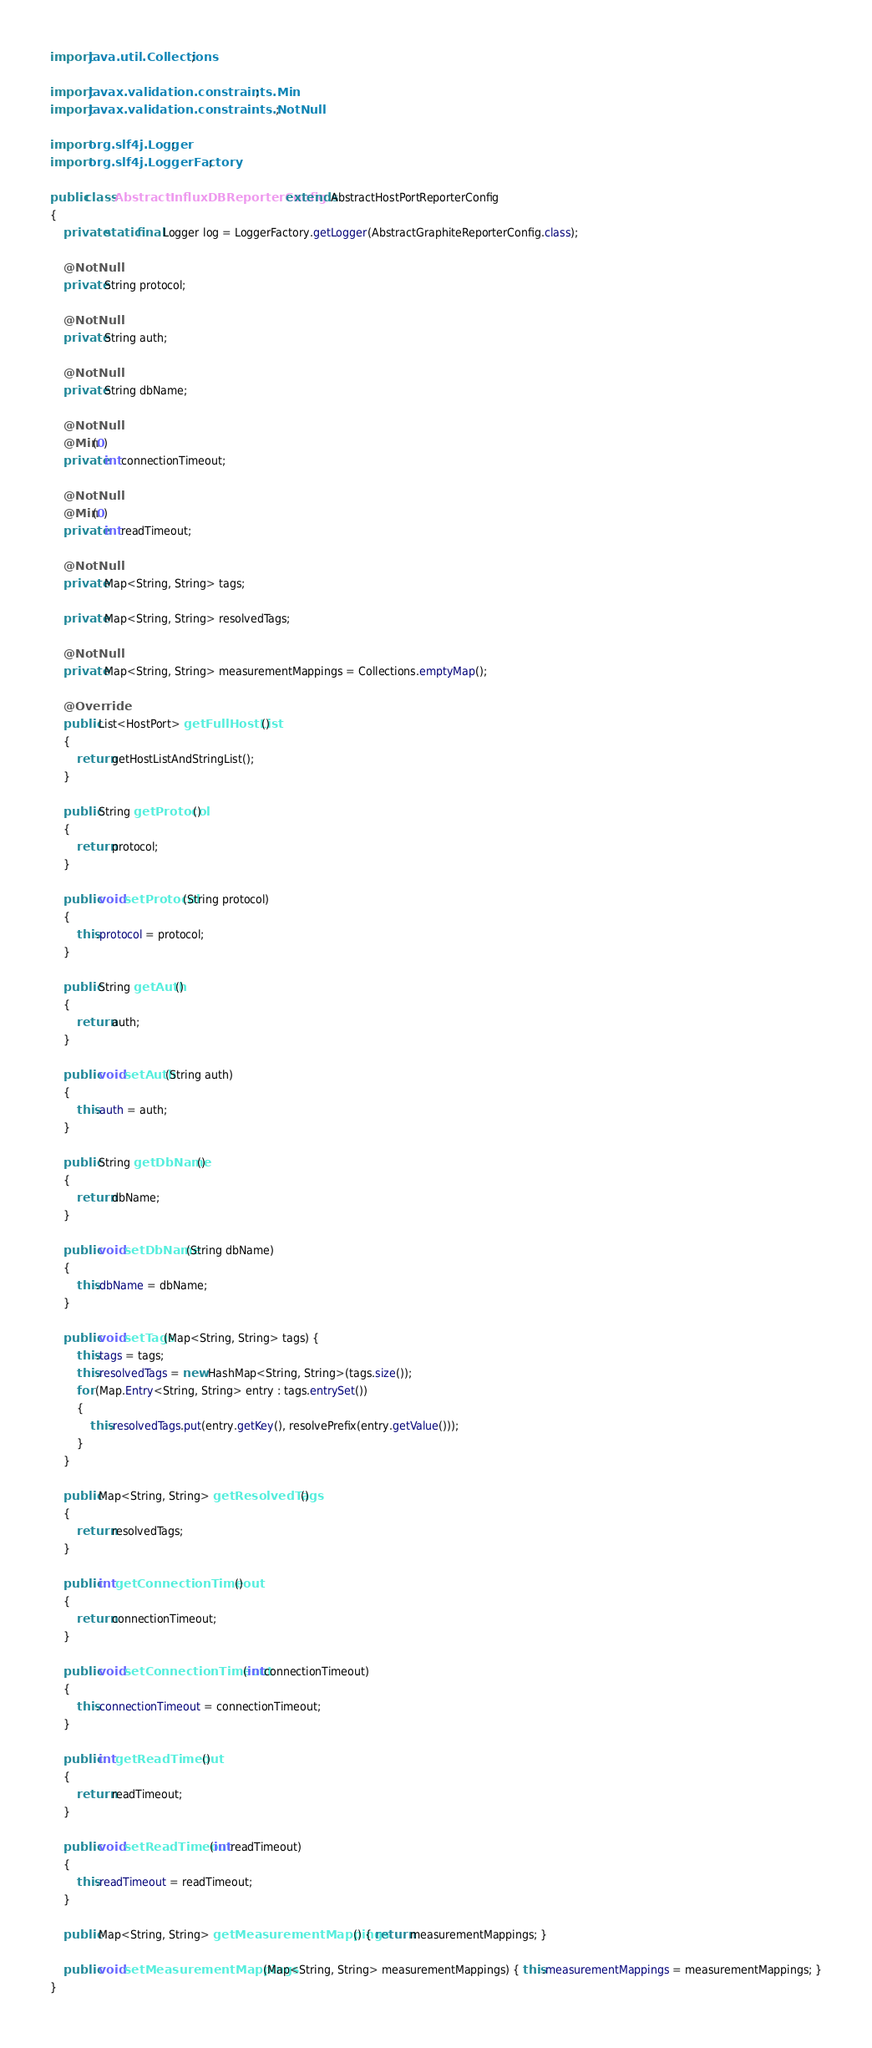Convert code to text. <code><loc_0><loc_0><loc_500><loc_500><_Java_>import java.util.Collections;

import javax.validation.constraints.Min;
import javax.validation.constraints.NotNull;

import org.slf4j.Logger;
import org.slf4j.LoggerFactory;

public class AbstractInfluxDBReporterConfig extends AbstractHostPortReporterConfig
{
    private static final Logger log = LoggerFactory.getLogger(AbstractGraphiteReporterConfig.class);

    @NotNull
    private String protocol;

    @NotNull
    private String auth;

    @NotNull
    private String dbName;

    @NotNull
    @Min(0)
    private int connectionTimeout;

    @NotNull
    @Min(0)
    private int readTimeout;

    @NotNull
    private Map<String, String> tags;

    private Map<String, String> resolvedTags;

    @NotNull
    private Map<String, String> measurementMappings = Collections.emptyMap();

    @Override
    public List<HostPort> getFullHostList()
    {
        return getHostListAndStringList();
    }

    public String getProtocol()
    {
        return protocol;
    }

    public void setProtocol(String protocol)
    {
        this.protocol = protocol;
    }

    public String getAuth()
    {
        return auth;
    }

    public void setAuth(String auth)
    {
        this.auth = auth;
    }

    public String getDbName()
    {
        return dbName;
    }

    public void setDbName(String dbName)
    {
        this.dbName = dbName;
    }

    public void setTags(Map<String, String> tags) {
        this.tags = tags;
        this.resolvedTags = new HashMap<String, String>(tags.size());
        for (Map.Entry<String, String> entry : tags.entrySet())
        {
            this.resolvedTags.put(entry.getKey(), resolvePrefix(entry.getValue()));
        }
    }

    public Map<String, String> getResolvedTags()
    {
        return resolvedTags;
    }

    public int getConnectionTimeout()
    {
        return connectionTimeout;
    }

    public void setConnectionTimeout(int connectionTimeout)
    {
        this.connectionTimeout = connectionTimeout;
    }

    public int getReadTimeout()
    {
        return readTimeout;
    }

    public void setReadTimeout(int readTimeout)
    {
        this.readTimeout = readTimeout;
    }

    public Map<String, String> getMeasurementMappings() { return measurementMappings; }

    public void setMeasurementMappings(Map<String, String> measurementMappings) { this.measurementMappings = measurementMappings; }
}
</code> 